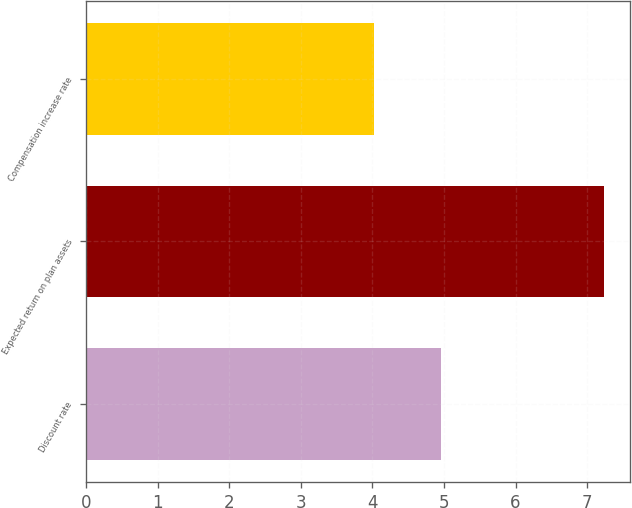<chart> <loc_0><loc_0><loc_500><loc_500><bar_chart><fcel>Discount rate<fcel>Expected return on plan assets<fcel>Compensation increase rate<nl><fcel>4.96<fcel>7.24<fcel>4.02<nl></chart> 